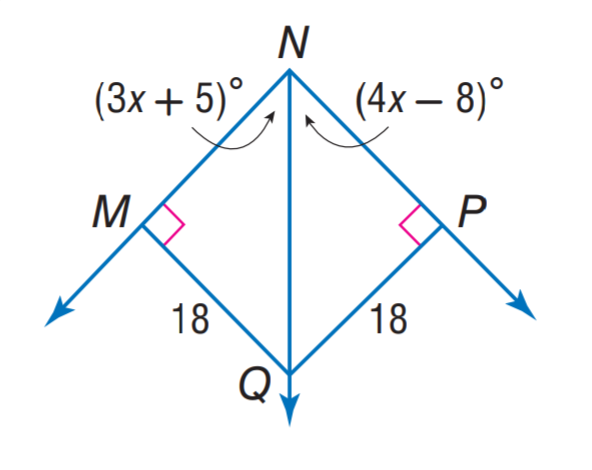Answer the mathemtical geometry problem and directly provide the correct option letter.
Question: Find m \angle P N M.
Choices: A: 36 B: 44 C: 63 D: 88 D 